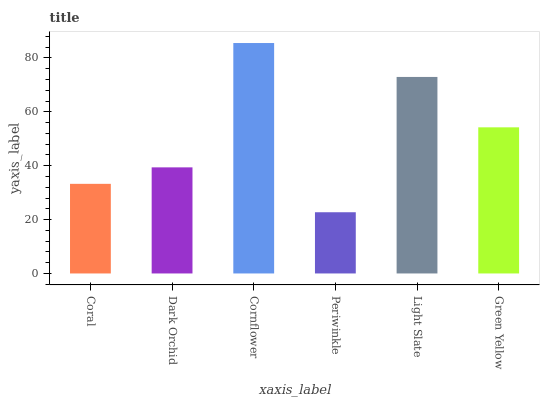Is Dark Orchid the minimum?
Answer yes or no. No. Is Dark Orchid the maximum?
Answer yes or no. No. Is Dark Orchid greater than Coral?
Answer yes or no. Yes. Is Coral less than Dark Orchid?
Answer yes or no. Yes. Is Coral greater than Dark Orchid?
Answer yes or no. No. Is Dark Orchid less than Coral?
Answer yes or no. No. Is Green Yellow the high median?
Answer yes or no. Yes. Is Dark Orchid the low median?
Answer yes or no. Yes. Is Dark Orchid the high median?
Answer yes or no. No. Is Coral the low median?
Answer yes or no. No. 